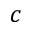Convert formula to latex. <formula><loc_0><loc_0><loc_500><loc_500>c</formula> 